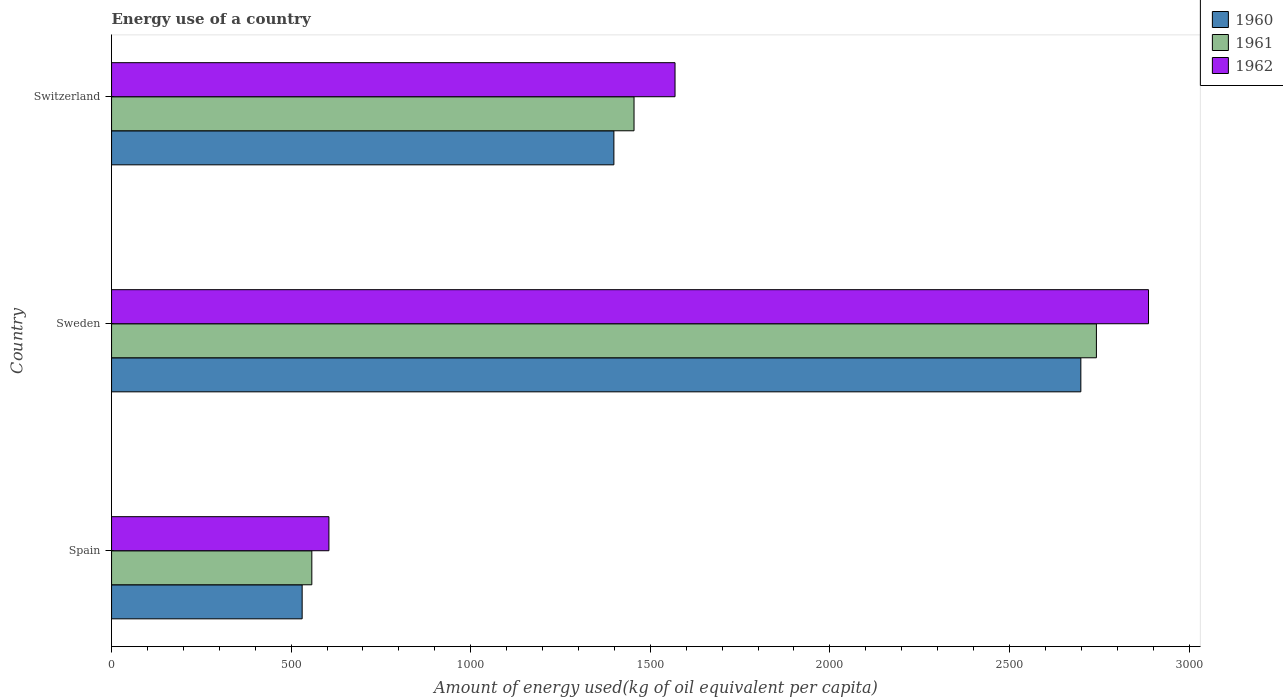How many different coloured bars are there?
Give a very brief answer. 3. Are the number of bars per tick equal to the number of legend labels?
Your answer should be very brief. Yes. Are the number of bars on each tick of the Y-axis equal?
Offer a terse response. Yes. What is the label of the 3rd group of bars from the top?
Provide a short and direct response. Spain. What is the amount of energy used in in 1960 in Switzerland?
Keep it short and to the point. 1398.65. Across all countries, what is the maximum amount of energy used in in 1960?
Ensure brevity in your answer.  2698.79. Across all countries, what is the minimum amount of energy used in in 1962?
Provide a succinct answer. 605.22. In which country was the amount of energy used in in 1960 maximum?
Provide a short and direct response. Sweden. What is the total amount of energy used in in 1960 in the graph?
Provide a succinct answer. 4628.11. What is the difference between the amount of energy used in in 1960 in Spain and that in Switzerland?
Give a very brief answer. -867.99. What is the difference between the amount of energy used in in 1962 in Spain and the amount of energy used in in 1960 in Sweden?
Offer a very short reply. -2093.57. What is the average amount of energy used in in 1961 per country?
Offer a terse response. 1584.83. What is the difference between the amount of energy used in in 1962 and amount of energy used in in 1960 in Switzerland?
Your answer should be very brief. 170.26. What is the ratio of the amount of energy used in in 1962 in Sweden to that in Switzerland?
Offer a terse response. 1.84. Is the amount of energy used in in 1962 in Spain less than that in Switzerland?
Your answer should be compact. Yes. What is the difference between the highest and the second highest amount of energy used in in 1961?
Your response must be concise. 1287.37. What is the difference between the highest and the lowest amount of energy used in in 1962?
Ensure brevity in your answer.  2282.01. In how many countries, is the amount of energy used in in 1960 greater than the average amount of energy used in in 1960 taken over all countries?
Make the answer very short. 1. Is the sum of the amount of energy used in in 1962 in Sweden and Switzerland greater than the maximum amount of energy used in in 1961 across all countries?
Offer a very short reply. Yes. What does the 3rd bar from the top in Switzerland represents?
Offer a very short reply. 1960. How many countries are there in the graph?
Keep it short and to the point. 3. What is the difference between two consecutive major ticks on the X-axis?
Provide a succinct answer. 500. Are the values on the major ticks of X-axis written in scientific E-notation?
Your answer should be compact. No. Does the graph contain any zero values?
Offer a very short reply. No. Where does the legend appear in the graph?
Provide a succinct answer. Top right. How many legend labels are there?
Offer a terse response. 3. How are the legend labels stacked?
Ensure brevity in your answer.  Vertical. What is the title of the graph?
Your answer should be very brief. Energy use of a country. Does "1995" appear as one of the legend labels in the graph?
Your answer should be very brief. No. What is the label or title of the X-axis?
Offer a terse response. Amount of energy used(kg of oil equivalent per capita). What is the label or title of the Y-axis?
Provide a short and direct response. Country. What is the Amount of energy used(kg of oil equivalent per capita) of 1960 in Spain?
Offer a very short reply. 530.66. What is the Amount of energy used(kg of oil equivalent per capita) of 1961 in Spain?
Your answer should be compact. 557.6. What is the Amount of energy used(kg of oil equivalent per capita) in 1962 in Spain?
Offer a very short reply. 605.22. What is the Amount of energy used(kg of oil equivalent per capita) of 1960 in Sweden?
Offer a very short reply. 2698.79. What is the Amount of energy used(kg of oil equivalent per capita) in 1961 in Sweden?
Your answer should be very brief. 2742.12. What is the Amount of energy used(kg of oil equivalent per capita) in 1962 in Sweden?
Provide a short and direct response. 2887.24. What is the Amount of energy used(kg of oil equivalent per capita) of 1960 in Switzerland?
Ensure brevity in your answer.  1398.65. What is the Amount of energy used(kg of oil equivalent per capita) in 1961 in Switzerland?
Give a very brief answer. 1454.76. What is the Amount of energy used(kg of oil equivalent per capita) of 1962 in Switzerland?
Provide a succinct answer. 1568.91. Across all countries, what is the maximum Amount of energy used(kg of oil equivalent per capita) in 1960?
Offer a very short reply. 2698.79. Across all countries, what is the maximum Amount of energy used(kg of oil equivalent per capita) in 1961?
Give a very brief answer. 2742.12. Across all countries, what is the maximum Amount of energy used(kg of oil equivalent per capita) in 1962?
Make the answer very short. 2887.24. Across all countries, what is the minimum Amount of energy used(kg of oil equivalent per capita) in 1960?
Give a very brief answer. 530.66. Across all countries, what is the minimum Amount of energy used(kg of oil equivalent per capita) of 1961?
Make the answer very short. 557.6. Across all countries, what is the minimum Amount of energy used(kg of oil equivalent per capita) of 1962?
Your answer should be compact. 605.22. What is the total Amount of energy used(kg of oil equivalent per capita) in 1960 in the graph?
Make the answer very short. 4628.11. What is the total Amount of energy used(kg of oil equivalent per capita) of 1961 in the graph?
Your answer should be very brief. 4754.48. What is the total Amount of energy used(kg of oil equivalent per capita) of 1962 in the graph?
Provide a short and direct response. 5061.37. What is the difference between the Amount of energy used(kg of oil equivalent per capita) in 1960 in Spain and that in Sweden?
Ensure brevity in your answer.  -2168.13. What is the difference between the Amount of energy used(kg of oil equivalent per capita) in 1961 in Spain and that in Sweden?
Provide a short and direct response. -2184.52. What is the difference between the Amount of energy used(kg of oil equivalent per capita) in 1962 in Spain and that in Sweden?
Keep it short and to the point. -2282.01. What is the difference between the Amount of energy used(kg of oil equivalent per capita) of 1960 in Spain and that in Switzerland?
Make the answer very short. -867.99. What is the difference between the Amount of energy used(kg of oil equivalent per capita) of 1961 in Spain and that in Switzerland?
Make the answer very short. -897.16. What is the difference between the Amount of energy used(kg of oil equivalent per capita) in 1962 in Spain and that in Switzerland?
Ensure brevity in your answer.  -963.69. What is the difference between the Amount of energy used(kg of oil equivalent per capita) in 1960 in Sweden and that in Switzerland?
Give a very brief answer. 1300.14. What is the difference between the Amount of energy used(kg of oil equivalent per capita) in 1961 in Sweden and that in Switzerland?
Provide a short and direct response. 1287.37. What is the difference between the Amount of energy used(kg of oil equivalent per capita) in 1962 in Sweden and that in Switzerland?
Make the answer very short. 1318.33. What is the difference between the Amount of energy used(kg of oil equivalent per capita) of 1960 in Spain and the Amount of energy used(kg of oil equivalent per capita) of 1961 in Sweden?
Your answer should be very brief. -2211.46. What is the difference between the Amount of energy used(kg of oil equivalent per capita) in 1960 in Spain and the Amount of energy used(kg of oil equivalent per capita) in 1962 in Sweden?
Keep it short and to the point. -2356.57. What is the difference between the Amount of energy used(kg of oil equivalent per capita) in 1961 in Spain and the Amount of energy used(kg of oil equivalent per capita) in 1962 in Sweden?
Provide a succinct answer. -2329.64. What is the difference between the Amount of energy used(kg of oil equivalent per capita) of 1960 in Spain and the Amount of energy used(kg of oil equivalent per capita) of 1961 in Switzerland?
Your answer should be compact. -924.09. What is the difference between the Amount of energy used(kg of oil equivalent per capita) of 1960 in Spain and the Amount of energy used(kg of oil equivalent per capita) of 1962 in Switzerland?
Keep it short and to the point. -1038.25. What is the difference between the Amount of energy used(kg of oil equivalent per capita) of 1961 in Spain and the Amount of energy used(kg of oil equivalent per capita) of 1962 in Switzerland?
Make the answer very short. -1011.31. What is the difference between the Amount of energy used(kg of oil equivalent per capita) of 1960 in Sweden and the Amount of energy used(kg of oil equivalent per capita) of 1961 in Switzerland?
Offer a very short reply. 1244.04. What is the difference between the Amount of energy used(kg of oil equivalent per capita) of 1960 in Sweden and the Amount of energy used(kg of oil equivalent per capita) of 1962 in Switzerland?
Offer a very short reply. 1129.88. What is the difference between the Amount of energy used(kg of oil equivalent per capita) of 1961 in Sweden and the Amount of energy used(kg of oil equivalent per capita) of 1962 in Switzerland?
Keep it short and to the point. 1173.21. What is the average Amount of energy used(kg of oil equivalent per capita) in 1960 per country?
Ensure brevity in your answer.  1542.7. What is the average Amount of energy used(kg of oil equivalent per capita) in 1961 per country?
Your answer should be very brief. 1584.83. What is the average Amount of energy used(kg of oil equivalent per capita) in 1962 per country?
Offer a very short reply. 1687.12. What is the difference between the Amount of energy used(kg of oil equivalent per capita) in 1960 and Amount of energy used(kg of oil equivalent per capita) in 1961 in Spain?
Your answer should be very brief. -26.93. What is the difference between the Amount of energy used(kg of oil equivalent per capita) in 1960 and Amount of energy used(kg of oil equivalent per capita) in 1962 in Spain?
Your answer should be compact. -74.56. What is the difference between the Amount of energy used(kg of oil equivalent per capita) in 1961 and Amount of energy used(kg of oil equivalent per capita) in 1962 in Spain?
Your answer should be very brief. -47.62. What is the difference between the Amount of energy used(kg of oil equivalent per capita) of 1960 and Amount of energy used(kg of oil equivalent per capita) of 1961 in Sweden?
Make the answer very short. -43.33. What is the difference between the Amount of energy used(kg of oil equivalent per capita) in 1960 and Amount of energy used(kg of oil equivalent per capita) in 1962 in Sweden?
Give a very brief answer. -188.44. What is the difference between the Amount of energy used(kg of oil equivalent per capita) in 1961 and Amount of energy used(kg of oil equivalent per capita) in 1962 in Sweden?
Your answer should be compact. -145.11. What is the difference between the Amount of energy used(kg of oil equivalent per capita) in 1960 and Amount of energy used(kg of oil equivalent per capita) in 1961 in Switzerland?
Provide a short and direct response. -56.1. What is the difference between the Amount of energy used(kg of oil equivalent per capita) in 1960 and Amount of energy used(kg of oil equivalent per capita) in 1962 in Switzerland?
Keep it short and to the point. -170.26. What is the difference between the Amount of energy used(kg of oil equivalent per capita) in 1961 and Amount of energy used(kg of oil equivalent per capita) in 1962 in Switzerland?
Provide a succinct answer. -114.16. What is the ratio of the Amount of energy used(kg of oil equivalent per capita) in 1960 in Spain to that in Sweden?
Offer a very short reply. 0.2. What is the ratio of the Amount of energy used(kg of oil equivalent per capita) of 1961 in Spain to that in Sweden?
Your response must be concise. 0.2. What is the ratio of the Amount of energy used(kg of oil equivalent per capita) of 1962 in Spain to that in Sweden?
Your response must be concise. 0.21. What is the ratio of the Amount of energy used(kg of oil equivalent per capita) of 1960 in Spain to that in Switzerland?
Your response must be concise. 0.38. What is the ratio of the Amount of energy used(kg of oil equivalent per capita) in 1961 in Spain to that in Switzerland?
Offer a terse response. 0.38. What is the ratio of the Amount of energy used(kg of oil equivalent per capita) of 1962 in Spain to that in Switzerland?
Your response must be concise. 0.39. What is the ratio of the Amount of energy used(kg of oil equivalent per capita) of 1960 in Sweden to that in Switzerland?
Give a very brief answer. 1.93. What is the ratio of the Amount of energy used(kg of oil equivalent per capita) in 1961 in Sweden to that in Switzerland?
Make the answer very short. 1.88. What is the ratio of the Amount of energy used(kg of oil equivalent per capita) in 1962 in Sweden to that in Switzerland?
Ensure brevity in your answer.  1.84. What is the difference between the highest and the second highest Amount of energy used(kg of oil equivalent per capita) in 1960?
Give a very brief answer. 1300.14. What is the difference between the highest and the second highest Amount of energy used(kg of oil equivalent per capita) of 1961?
Offer a very short reply. 1287.37. What is the difference between the highest and the second highest Amount of energy used(kg of oil equivalent per capita) of 1962?
Provide a short and direct response. 1318.33. What is the difference between the highest and the lowest Amount of energy used(kg of oil equivalent per capita) of 1960?
Give a very brief answer. 2168.13. What is the difference between the highest and the lowest Amount of energy used(kg of oil equivalent per capita) of 1961?
Offer a very short reply. 2184.52. What is the difference between the highest and the lowest Amount of energy used(kg of oil equivalent per capita) in 1962?
Ensure brevity in your answer.  2282.01. 